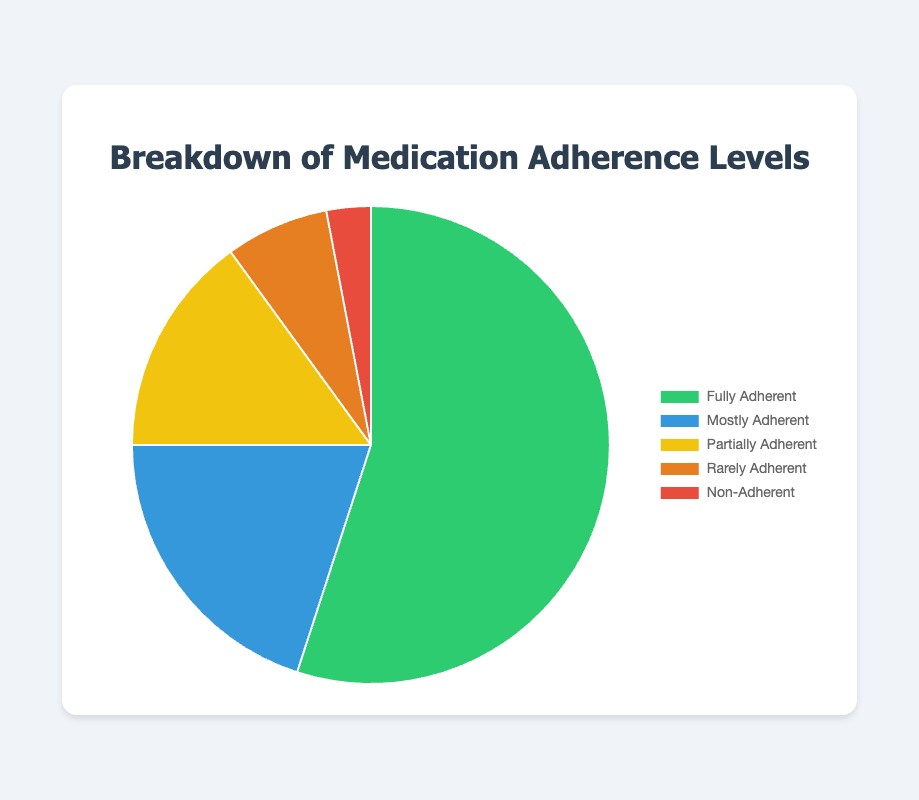What is the percentage of people who are Fully Adherent? The chart shows the adherence levels. The sector labeled "Fully Adherent" has a percentage value next to it. By looking at it, we can see it says 55%.
Answer: 55% What is the difference in percentage between Mostly Adherent and Rarely Adherent? Find the labels "Mostly Adherent" and "Rarely Adherent" and note their percentages: 20% and 7% respectively. Subtract the lower percentage from the higher one: 20% - 7% = 13%.
Answer: 13% How much more frequent is Full Adherence compared to Non-Adherence? Locate the labels "Fully Adherent" and "Non-Adherent". Their percentages are 55% and 3%. The difference is calculated as 55% - 3% = 52%.
Answer: 52% What percentage of people are either Fully Adherent or Mostly Adherent? The chart shows 55% for Fully Adherent and 20% for Mostly Adherent. Add the two percentages together: 55% + 20% = 75%.
Answer: 75% Which adherence level has the smallest percentage? By examining the chart, the "Non-Adherent" category has the smallest segment with 3%.
Answer: Non-Adherent Which two adherence levels combined equal 22%? Look for two segments whose percentages sum to 22%. "Rarely Adherent" with 7% and "Non-Adherent" with 3% do not add up to 22%. "Partially Adherent" with 15% and "Rarely Adherent" with 7% combine to give 22%.
Answer: Partially Adherent and Rarely Adherent What is the average percentage of the three adherence levels with the smallest values? Identify the three smallest categories: "Partially Adherent" with 15%, "Rarely Adherent" with 7%, and "Non-Adherent" with 3%. Calculate the average: (15% + 7% + 3%) / 3 = 25% / 3 = approximately 8.33%.
Answer: 8.33% If only Fully Adherent and Mostly Adherent levels are considered, what percentage of this subset is Fully Adherent? Fully Adherent is 55% and Mostly Adherent is 20%. The sum of these two levels is 55% + 20% = 75%. The percentage of Fully Adherent in this subset is calculated as (55 / 75) * 100% = approximately 73.33%.
Answer: 73.33% Which adherence level is represented by the blue color? In the pie chart, the color blue corresponds to the "Mostly Adherent" category with 20%.
Answer: Mostly Adherent 